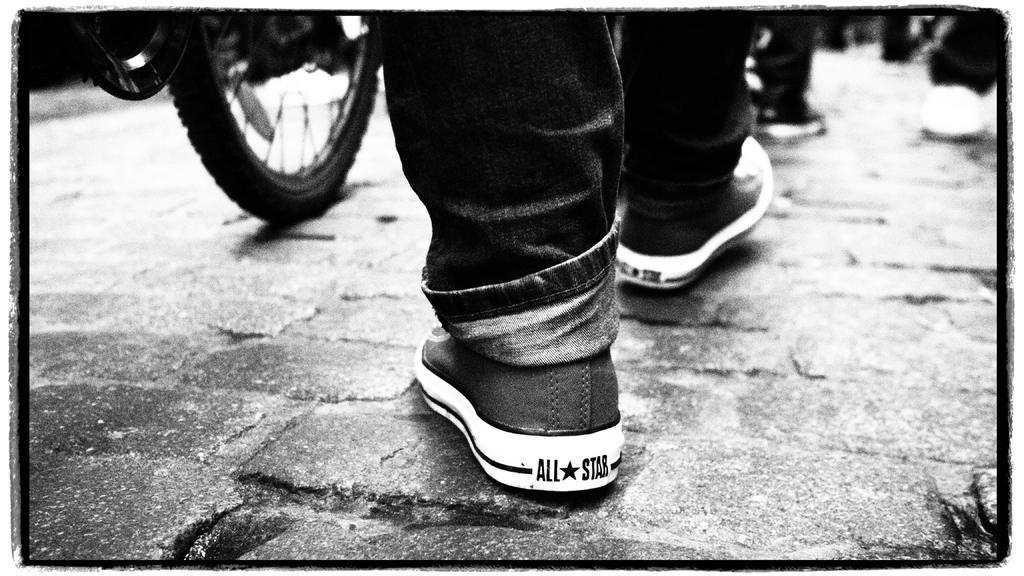Please provide a concise description of this image. This image is a black and white image. This image is taken outdoors. At the bottom of the image there is a road. In the middle of the image a few people are walking on the road and there is a bicycle parked on the road. 